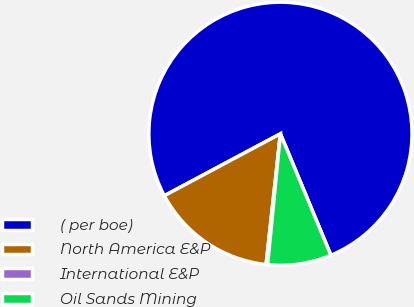<chart> <loc_0><loc_0><loc_500><loc_500><pie_chart><fcel>( per boe)<fcel>North America E&P<fcel>International E&P<fcel>Oil Sands Mining<nl><fcel>76.53%<fcel>15.46%<fcel>0.19%<fcel>7.82%<nl></chart> 